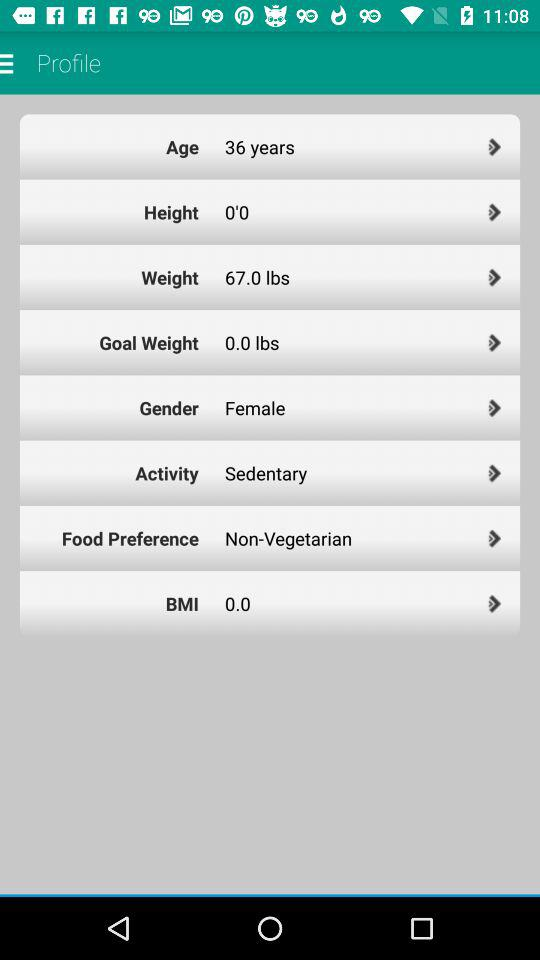For which setting is the selected option "Non-Vegetarian"? The selected option "Non-Vegetarian" is for the "Food Preference" setting. 